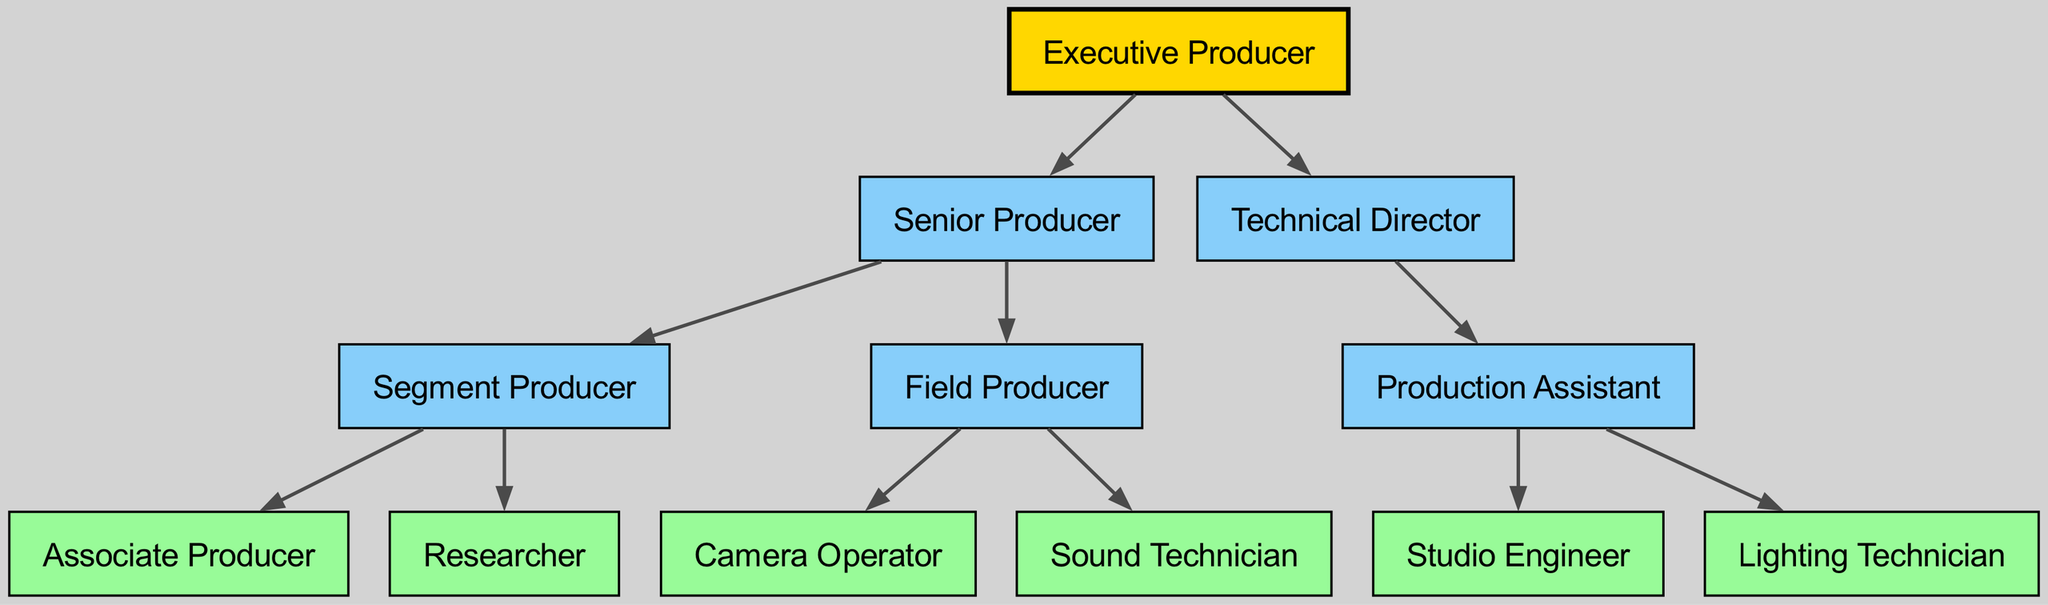What is the root label of the hierarchy? The root label of the diagram, representing the top position in the structure, is given as "Executive Producer."
Answer: Executive Producer How many main branches are there under the Executive Producer? The diagram shows two main branches: "Senior Producer" and "Technical Director," which are directly connected to the "Executive Producer."
Answer: 2 Who is the parent of the Segment Producer? Tracing the diagram, the "Segment Producer" is a child node of the "Senior Producer," making "Senior Producer" its parent.
Answer: Senior Producer Which role is under both the Senior Producer and Field Producer? There are no roles listed under both "Senior Producer" and "Field Producer," but "Segment Producer" is under "Senior Producer" and includes "Associate Producer" and "Researcher"; therefore, the inquiry may refer mistakenly to a commonality.
Answer: None How many nodes are there under the Technical Director? Under "Technical Director," there is one node, which is "Production Assistant," and this node also has its own child nodes.
Answer: 1 How many total child nodes does the Field Producer have? The "Field Producer" has two child nodes: "Camera Operator" and "Sound Technician," which makes a total of two direct children.
Answer: 2 Which node has the highest position in this hierarchy? The highest position in the hierarchy is represented by the root label, which is the first node in the hierarchy structure, "Executive Producer."
Answer: Executive Producer What is the role immediately below the Technical Director? Below the "Technical Director," the immediate role is the "Production Assistant," which is directly connected as a child node.
Answer: Production Assistant Which role is responsible for hands-on production tasks in the field? The "Field Producer" is responsible for hands-on production tasks in the field according to their role in the hierarchy.
Answer: Field Producer Who has the least number of direct reports? The "Associate Producer" has no direct reports, making them the role with the least number of direct connections in the diagram.
Answer: Associate Producer 